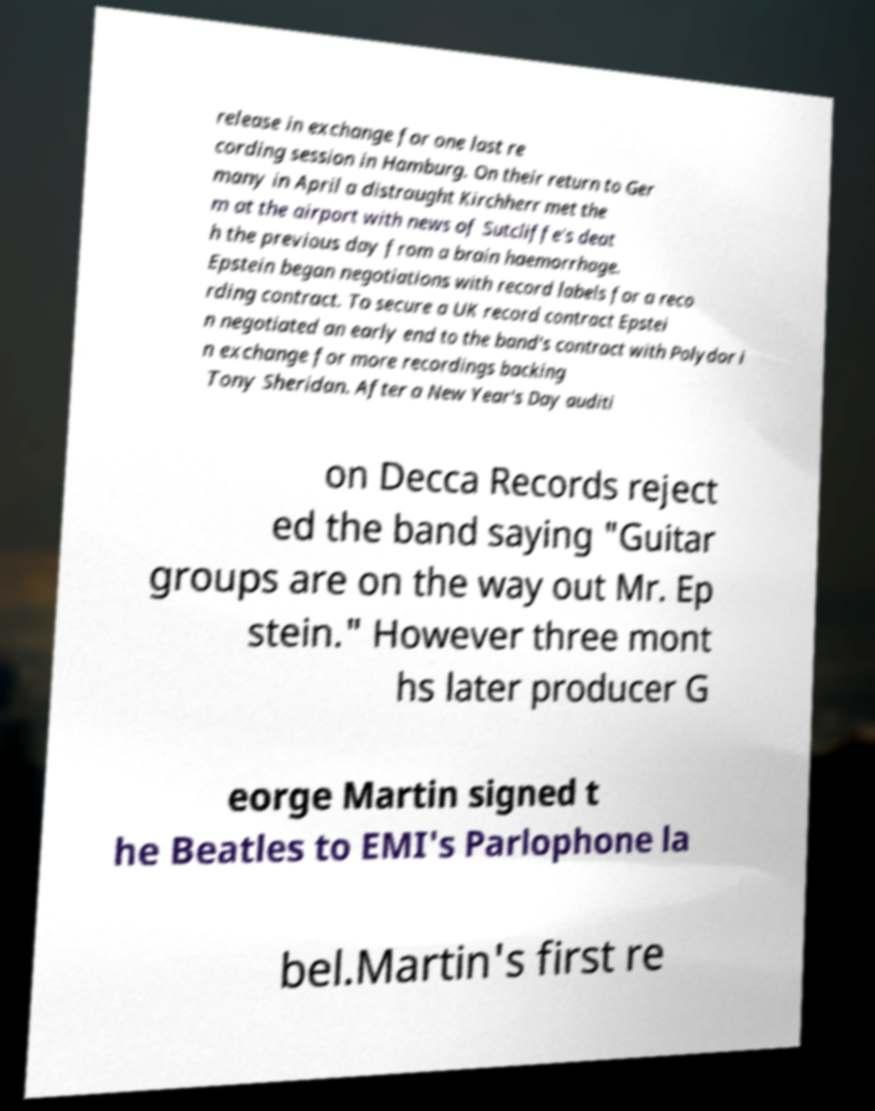Could you assist in decoding the text presented in this image and type it out clearly? release in exchange for one last re cording session in Hamburg. On their return to Ger many in April a distraught Kirchherr met the m at the airport with news of Sutcliffe's deat h the previous day from a brain haemorrhage. Epstein began negotiations with record labels for a reco rding contract. To secure a UK record contract Epstei n negotiated an early end to the band's contract with Polydor i n exchange for more recordings backing Tony Sheridan. After a New Year's Day auditi on Decca Records reject ed the band saying "Guitar groups are on the way out Mr. Ep stein." However three mont hs later producer G eorge Martin signed t he Beatles to EMI's Parlophone la bel.Martin's first re 